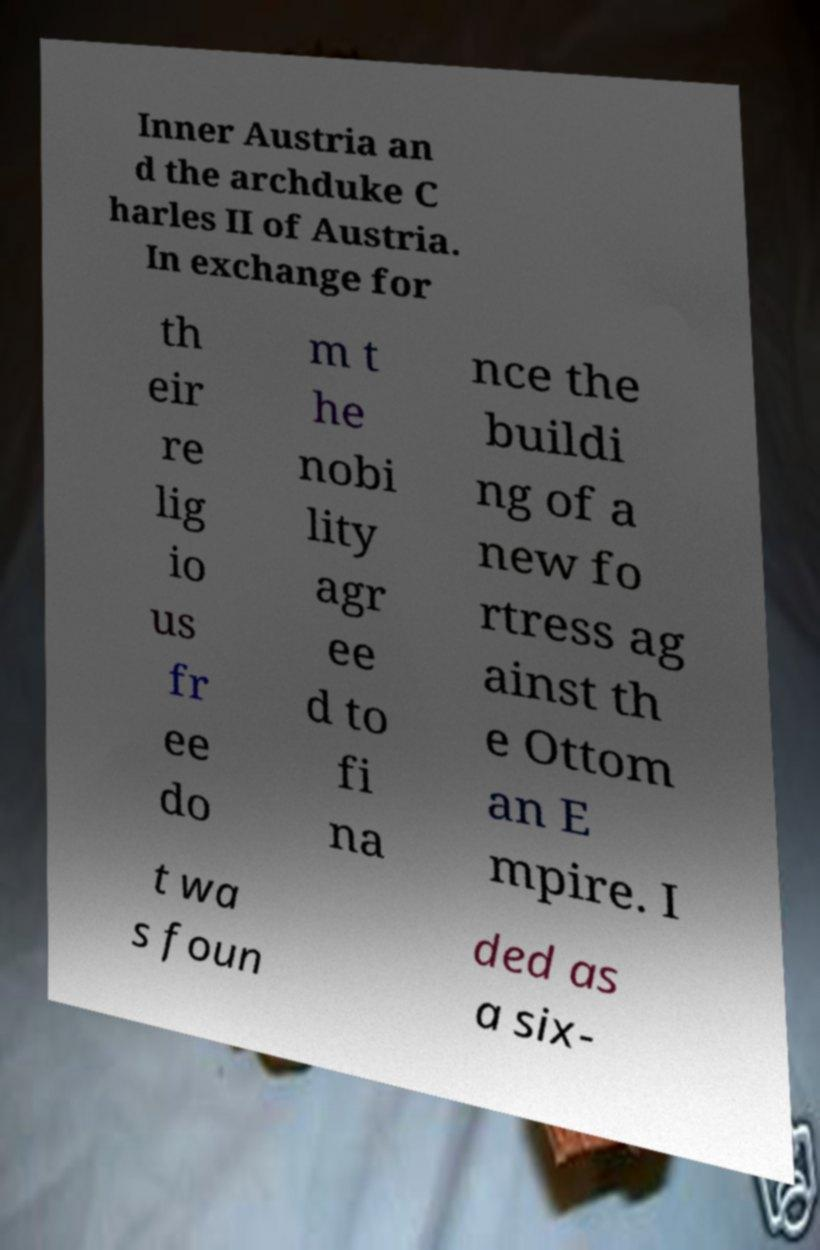There's text embedded in this image that I need extracted. Can you transcribe it verbatim? Inner Austria an d the archduke C harles II of Austria. In exchange for th eir re lig io us fr ee do m t he nobi lity agr ee d to fi na nce the buildi ng of a new fo rtress ag ainst th e Ottom an E mpire. I t wa s foun ded as a six- 